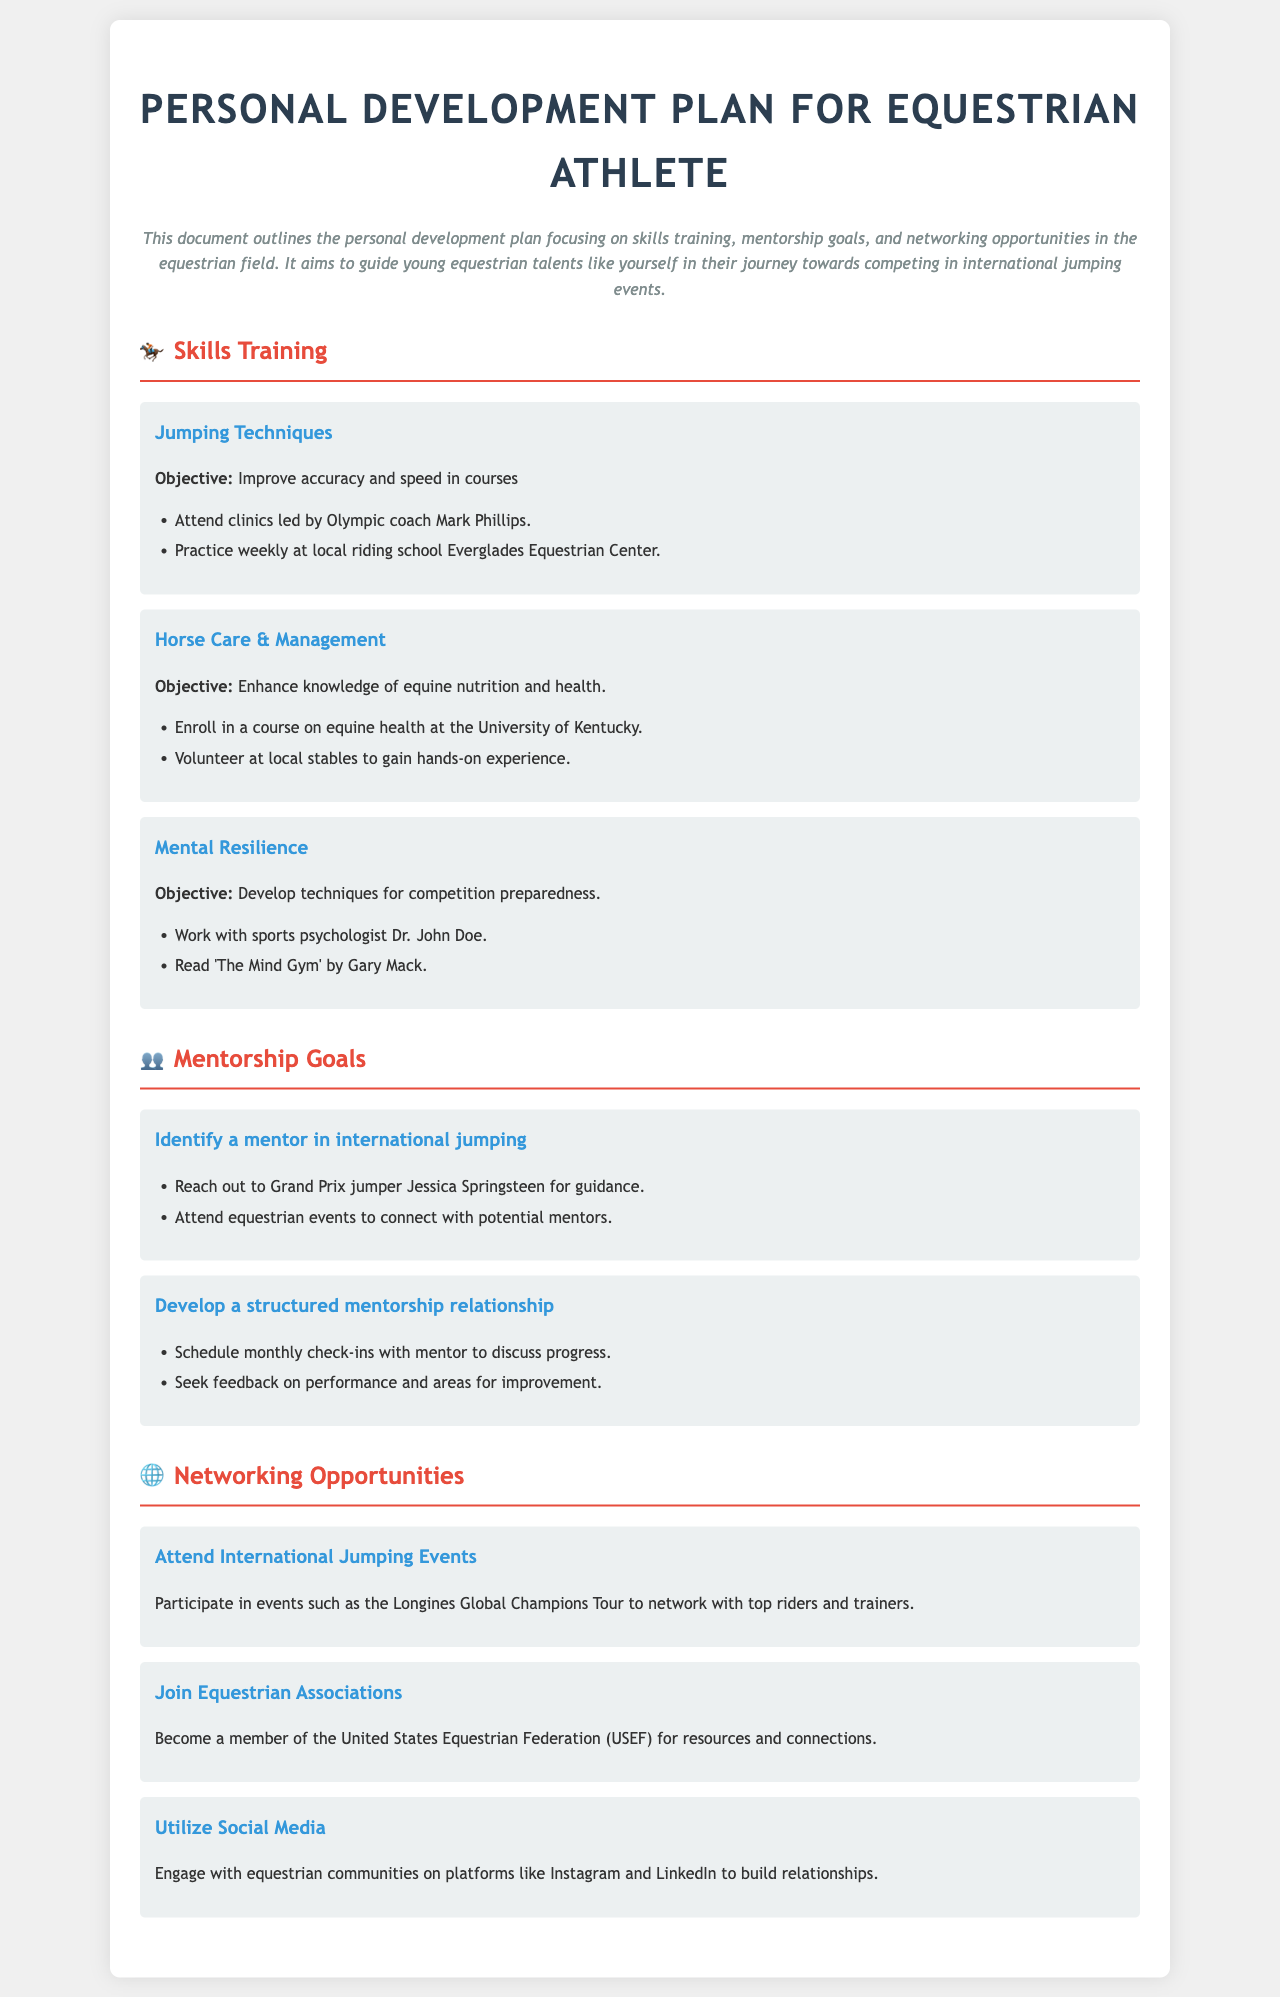What is the primary focus of the personal development plan? The document outlines a personal development plan focusing on skills training, mentorship goals, and networking opportunities in the equestrian field.
Answer: Skills training, mentorship goals, and networking opportunities Who is the Olympic coach mentioned for jumping techniques? The document specifies Olympic coach Mark Phillips as the coach for jumping techniques.
Answer: Mark Phillips What is one of the objectives for improving jumping techniques? The objective stated in the document for improving jumping techniques is to enhance accuracy and speed in courses.
Answer: Improve accuracy and speed in courses Name a resource recommended for developing mental resilience. The document suggests reading 'The Mind Gym' by Gary Mack as a resource for mental resilience.
Answer: The Mind Gym What type of events should you attend to network with top riders? The document mentions attending international jumping events, specifically the Longines Global Champions Tour.
Answer: Longines Global Champions Tour How often should check-ins with a mentor be scheduled? The document recommends scheduling monthly check-ins with the mentor.
Answer: Monthly What association should one join for resources and connections? The document advises becoming a member of the United States Equestrian Federation (USEF) for resources and connections.
Answer: United States Equestrian Federation What is one method suggested for engaging with equestrian communities? The document suggests utilizing social media platforms like Instagram and LinkedIn to engage with equestrian communities.
Answer: Social media What is one hands-on experience suggested for horse care and management? The document states that volunteering at local stables is a recommended hands-on experience for horse care.
Answer: Volunteer at local stables 